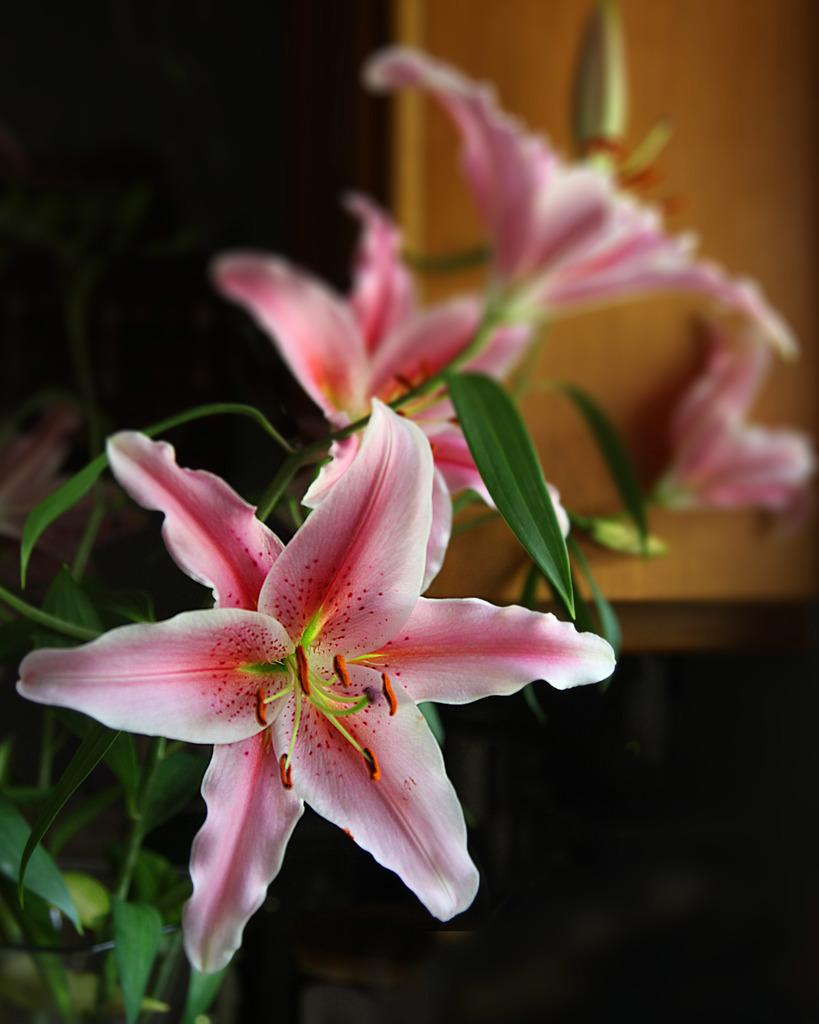What colors are the flowers in the image? The flowers in the image are pink and white. What are the flowers growing on? The flowers are on plants. Can you describe the background of the image? The background of the image is blurred. What type of oven is visible in the image? There is no oven present in the image; it features pink and white flowers on plants with a blurred background. What things can be seen cooking in the stew in the image? There is no stew present in the image; it features flowers on plants with a blurred background. 